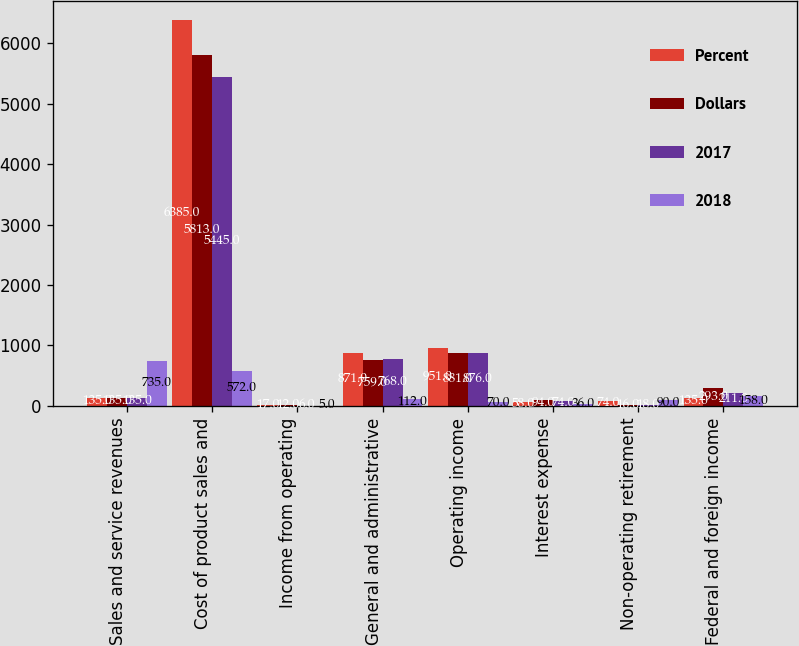<chart> <loc_0><loc_0><loc_500><loc_500><stacked_bar_chart><ecel><fcel>Sales and service revenues<fcel>Cost of product sales and<fcel>Income from operating<fcel>General and administrative<fcel>Operating income<fcel>Interest expense<fcel>Non-operating retirement<fcel>Federal and foreign income<nl><fcel>Percent<fcel>135<fcel>6385<fcel>17<fcel>871<fcel>951<fcel>58<fcel>74<fcel>135<nl><fcel>Dollars<fcel>135<fcel>5813<fcel>12<fcel>759<fcel>881<fcel>94<fcel>16<fcel>293<nl><fcel>2017<fcel>135<fcel>5445<fcel>6<fcel>768<fcel>876<fcel>74<fcel>18<fcel>211<nl><fcel>2018<fcel>735<fcel>572<fcel>5<fcel>112<fcel>70<fcel>36<fcel>90<fcel>158<nl></chart> 